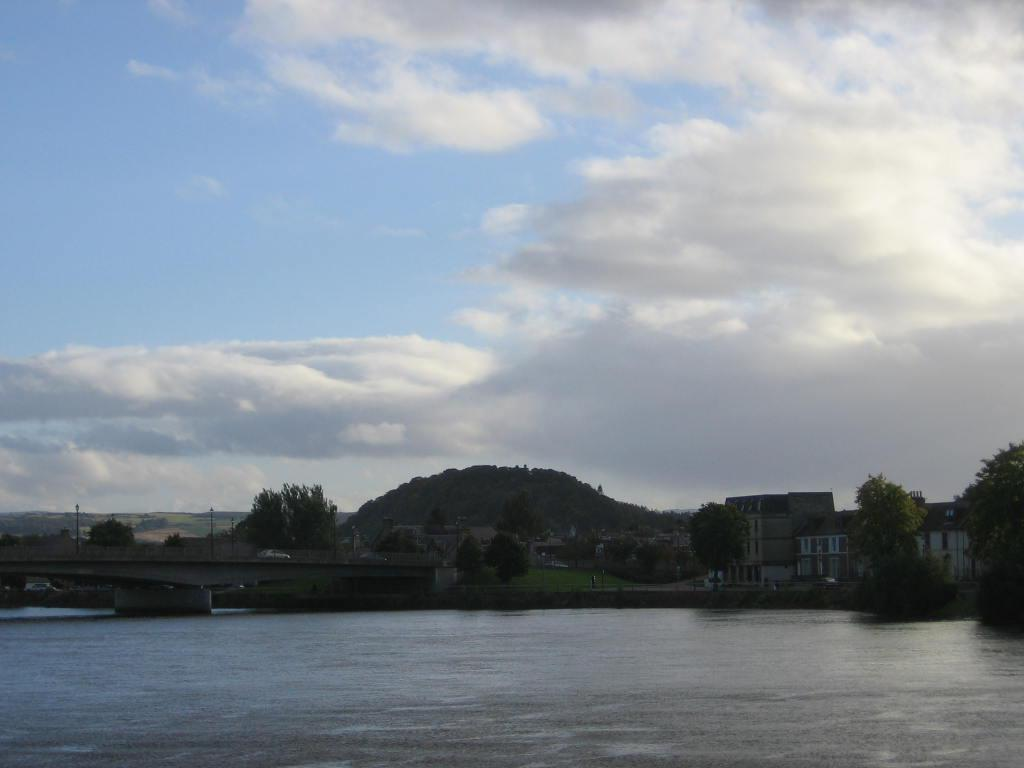What type of natural feature is present in the image? There is a river in the image. What is the vehicle doing in the image? A vehicle is moving on a bridge in the image. What type of vegetation can be seen in the image? There are trees in the image. What type of man-made structures are present in the image? There are buildings in the image. What type of geographical feature is visible in the background of the image? There are mountains in the image. What part of the natural environment is visible in the image? The sky is visible in the image. How many kittens are playing with a love hydrant in the picture? There are no kittens, love, or hydrants present in the image. 